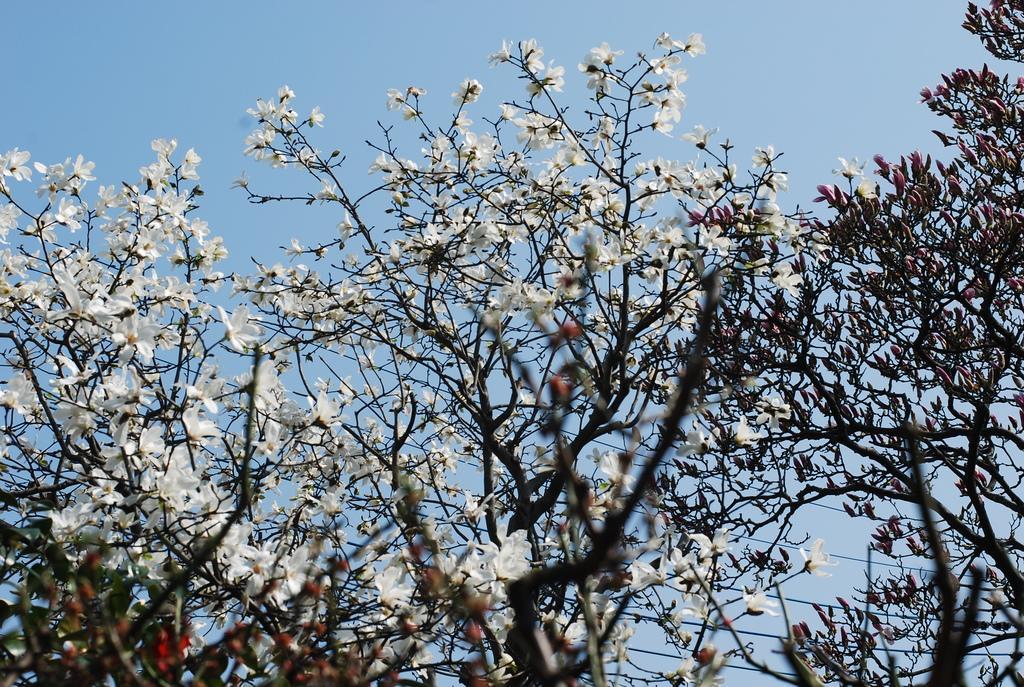Can you describe this image briefly? In the image we can see some trees and flowers. Behind the trees there is sky. 